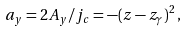<formula> <loc_0><loc_0><loc_500><loc_500>a _ { y } = 2 A _ { y } / j _ { c } = - ( z - z _ { \gamma } ) ^ { 2 } \, ,</formula> 